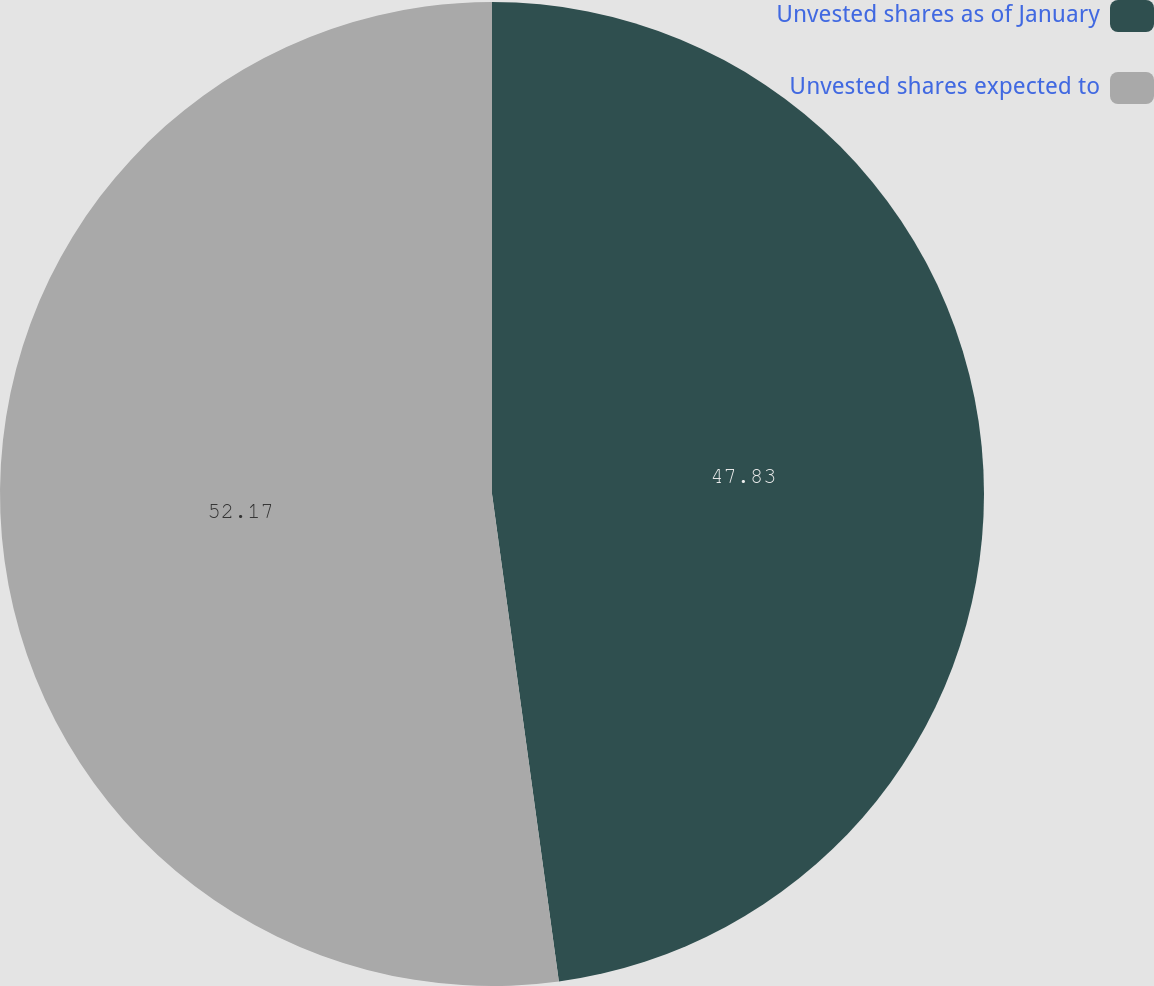<chart> <loc_0><loc_0><loc_500><loc_500><pie_chart><fcel>Unvested shares as of January<fcel>Unvested shares expected to<nl><fcel>47.83%<fcel>52.17%<nl></chart> 